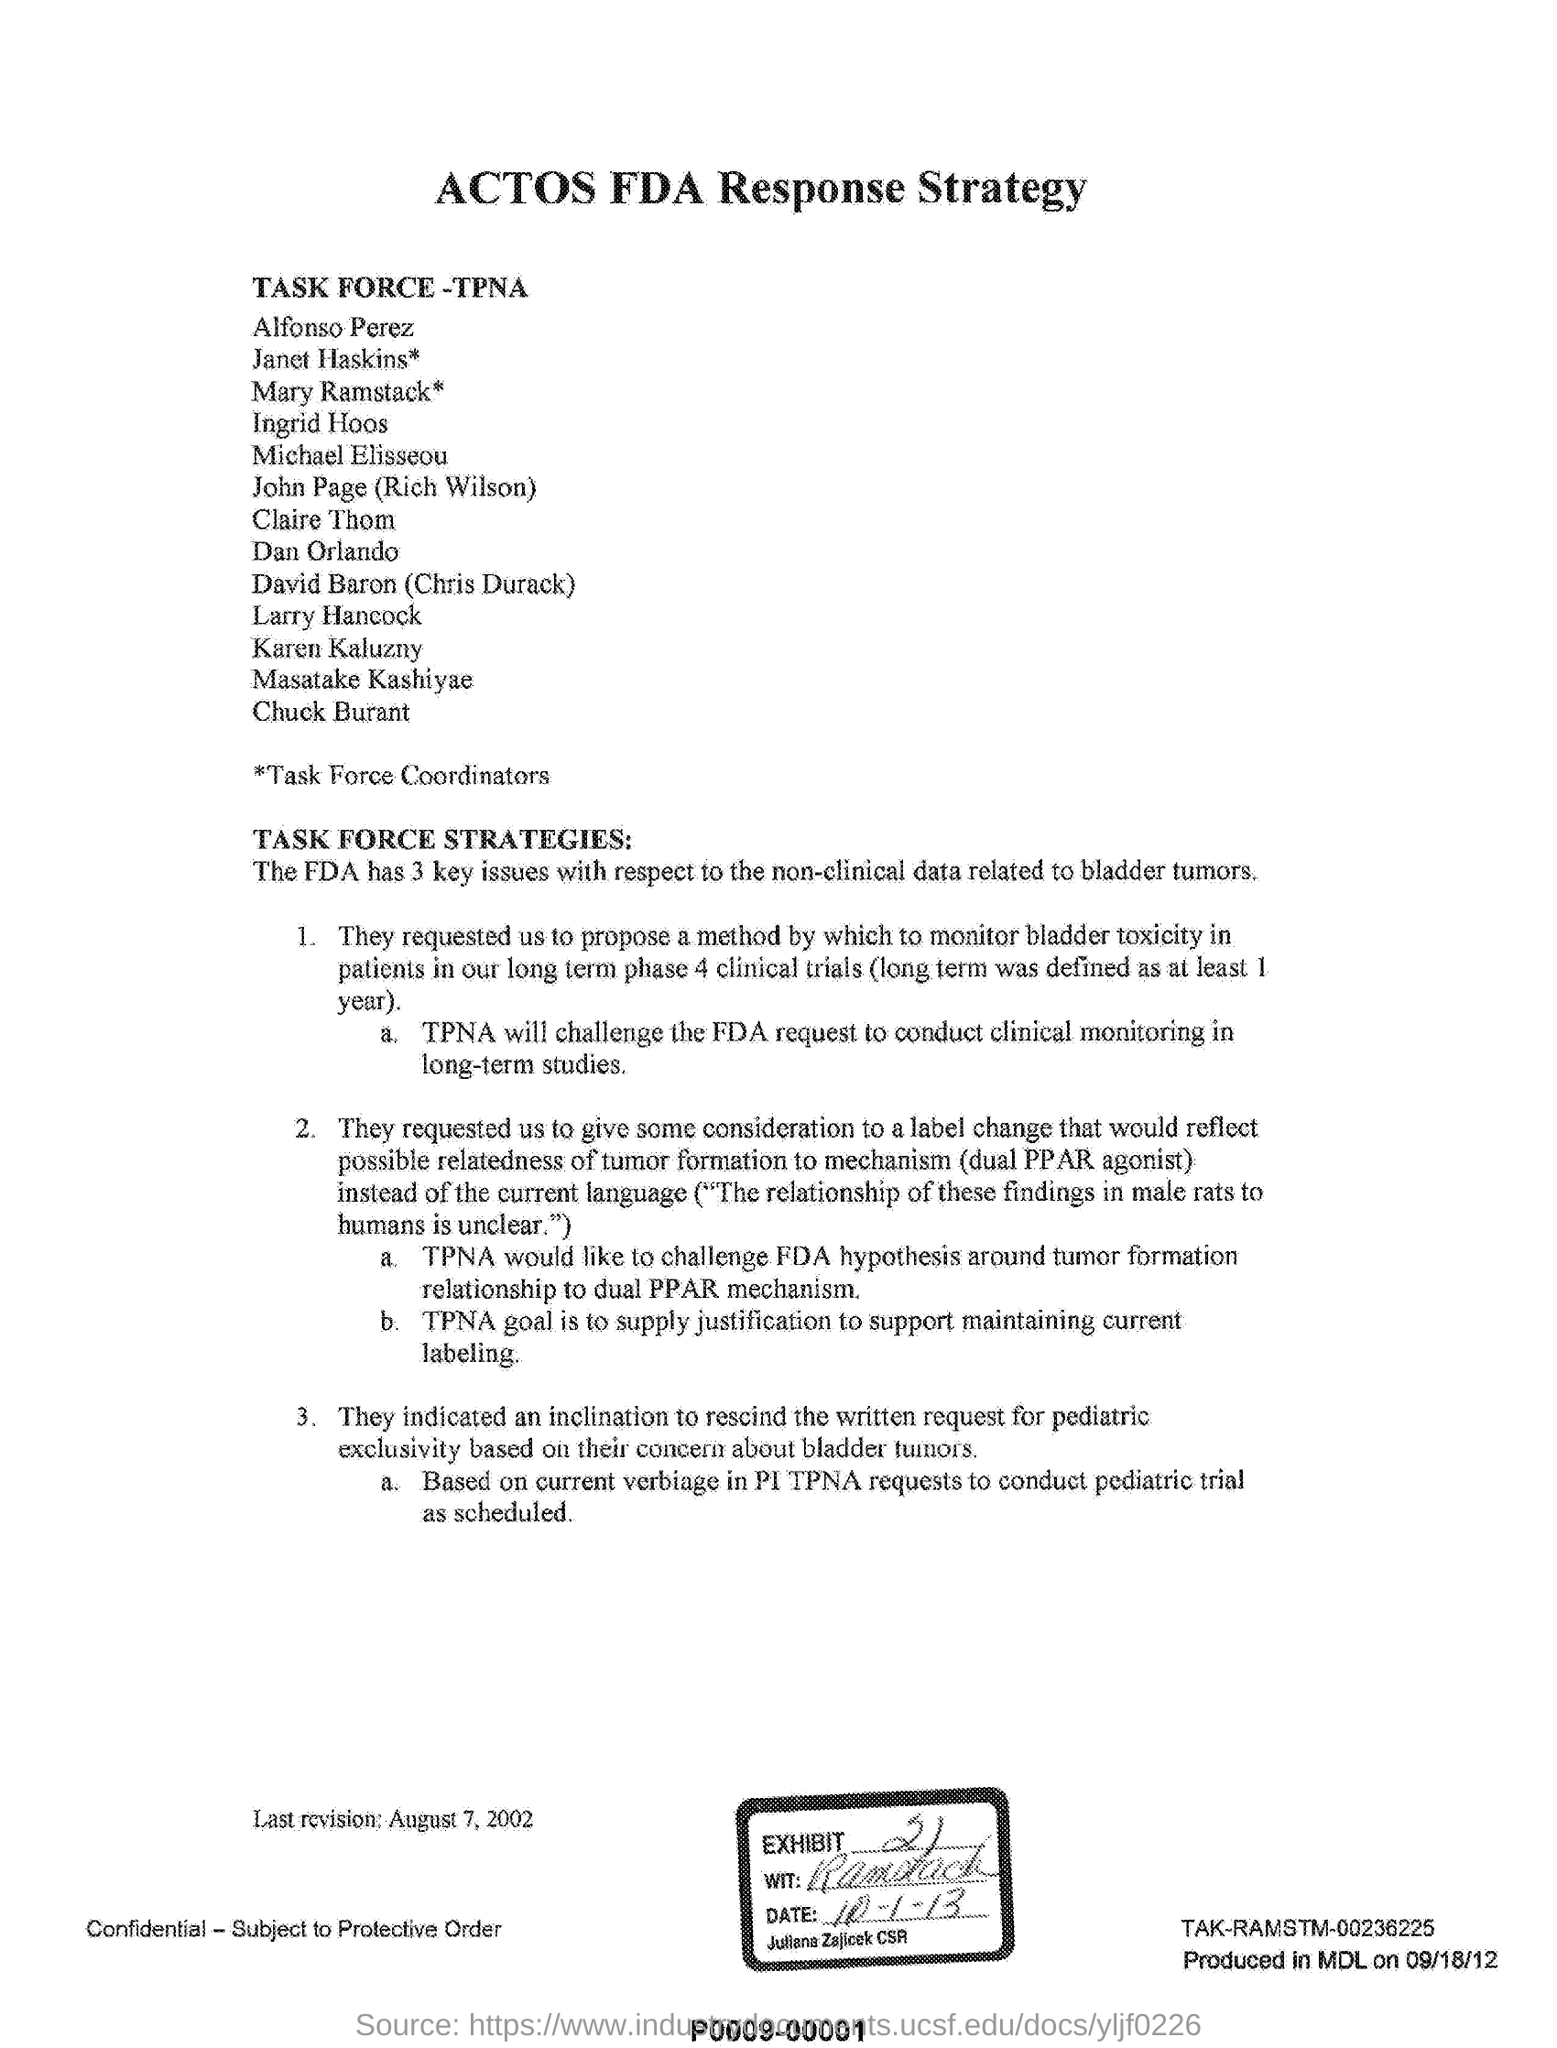Indicate a few pertinent items in this graphic. The goal of the Tobacco Products Scientific Advisory Board (TPSA) is to provide scientific guidance and advice to the Food and Drug Administration (FDA) Commissioner, and to help ensure that tobacco products are safe and do not harm public health. The justification for maintaining current labeling for tobacco products is to ensure that consumers have access to accurate and reliable information about the risks and benefits associated with these products, and to support the FDA's efforts to protect public health. The last revision date mentioned in this document is August 7, 2002. The heading of this document is 'ACTOS FDA Response Strategy.' 